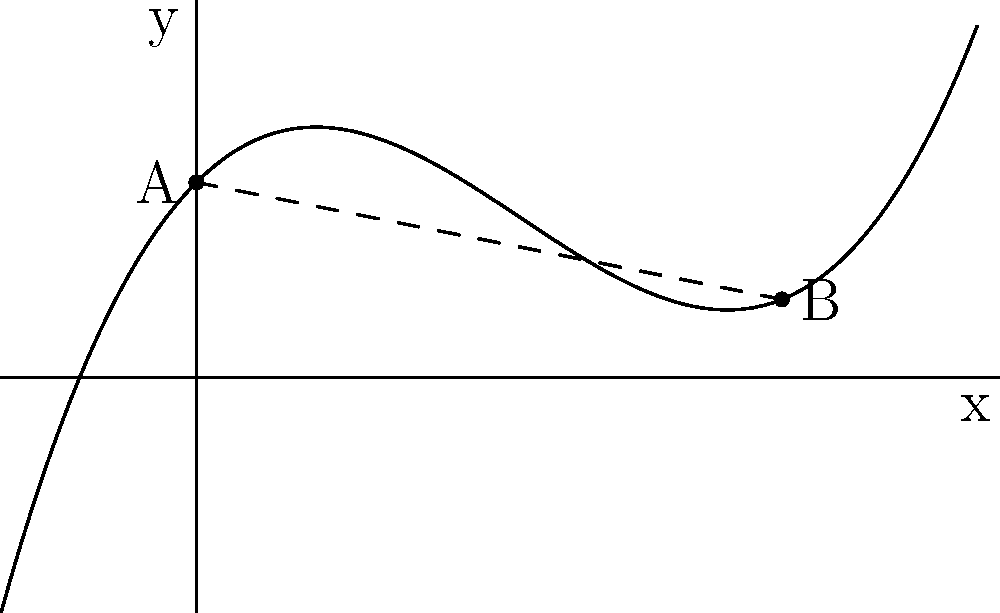You're designing an ergonomic, curved surface for a new handheld gadget. The curve is modeled by the polynomial function $f(x) = 0.05x^3 - 0.5x^2 + x + 2$, where $x$ and $f(x)$ are in centimeters. If point A is at (0, 2) and point B is at (6, $f(6)$), what is the total arc length of the curve between these two points, rounded to the nearest 0.1 cm? To find the arc length of a curve defined by a function $f(x)$ between two points, we use the arc length formula:

$$ L = \int_{a}^{b} \sqrt{1 + [f'(x)]^2} dx $$

where $a$ and $b$ are the x-coordinates of the start and end points.

Steps:
1) First, find $f'(x)$:
   $f'(x) = 0.15x^2 - x + 1$

2) Substitute this into the arc length formula:
   $$ L = \int_{0}^{6} \sqrt{1 + (0.15x^2 - x + 1)^2} dx $$

3) This integral is too complex to solve analytically, so we need to use numerical integration. We can use a computer algebra system or a numerical integration method like Simpson's rule.

4) Using a computer algebra system, we get:
   $L \approx 6.7041$ cm

5) Rounding to the nearest 0.1 cm:
   $L \approx 6.7$ cm

This arc length represents the total curved surface length of the gadget between points A and B.
Answer: 6.7 cm 